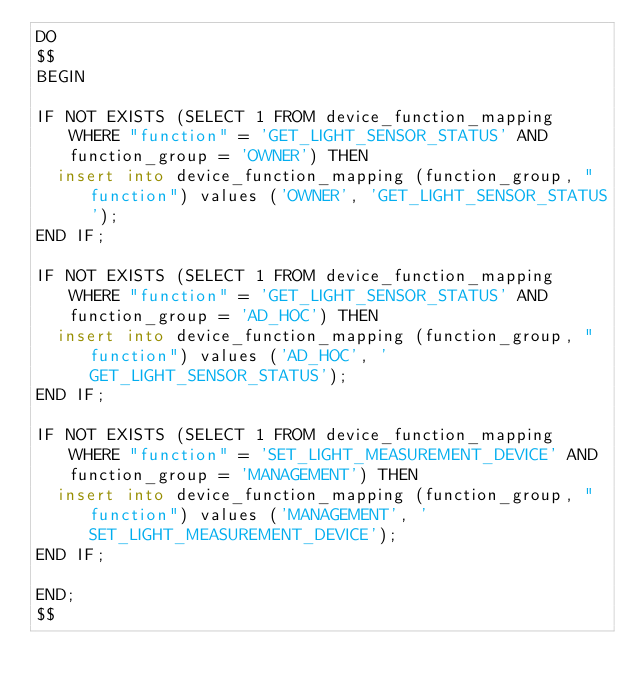<code> <loc_0><loc_0><loc_500><loc_500><_SQL_>DO
$$
BEGIN

IF NOT EXISTS (SELECT 1 FROM device_function_mapping WHERE "function" = 'GET_LIGHT_SENSOR_STATUS' AND function_group = 'OWNER') THEN
	insert into device_function_mapping (function_group, "function") values ('OWNER', 'GET_LIGHT_SENSOR_STATUS');
END IF;

IF NOT EXISTS (SELECT 1 FROM device_function_mapping WHERE "function" = 'GET_LIGHT_SENSOR_STATUS' AND function_group = 'AD_HOC') THEN
	insert into device_function_mapping (function_group, "function") values ('AD_HOC', 'GET_LIGHT_SENSOR_STATUS');
END IF;

IF NOT EXISTS (SELECT 1 FROM device_function_mapping WHERE "function" = 'SET_LIGHT_MEASUREMENT_DEVICE' AND function_group = 'MANAGEMENT') THEN
	insert into device_function_mapping (function_group, "function") values ('MANAGEMENT', 'SET_LIGHT_MEASUREMENT_DEVICE');
END IF;

END;
$$
</code> 